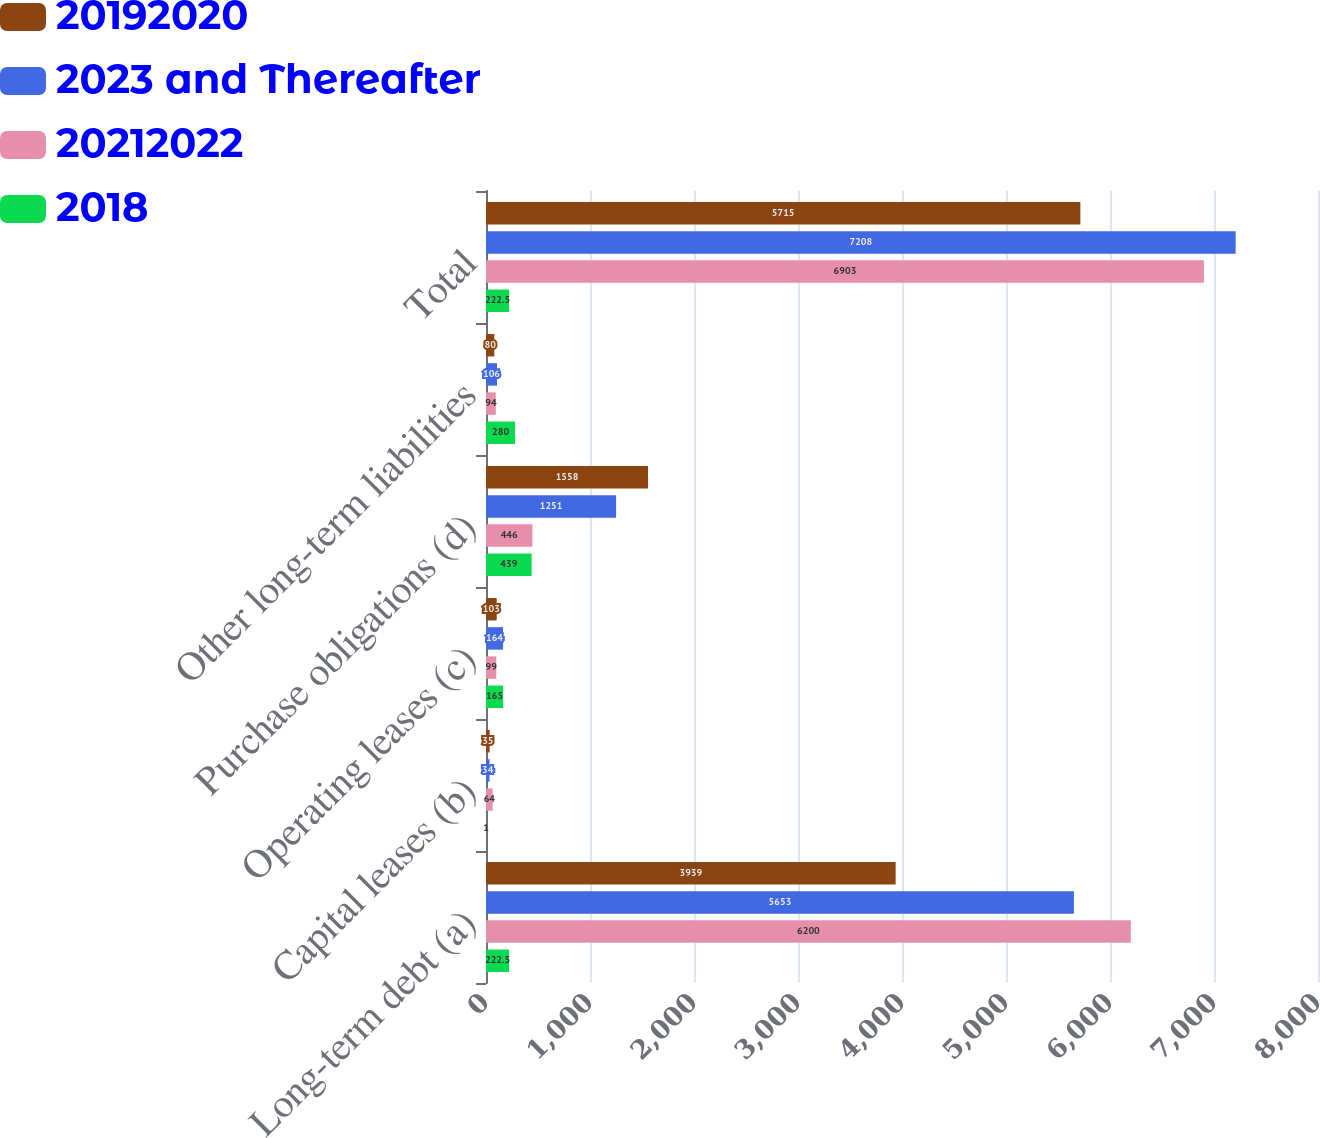Convert chart. <chart><loc_0><loc_0><loc_500><loc_500><stacked_bar_chart><ecel><fcel>Long-term debt (a)<fcel>Capital leases (b)<fcel>Operating leases (c)<fcel>Purchase obligations (d)<fcel>Other long-term liabilities<fcel>Total<nl><fcel>20192020<fcel>3939<fcel>35<fcel>103<fcel>1558<fcel>80<fcel>5715<nl><fcel>2023 and Thereafter<fcel>5653<fcel>34<fcel>164<fcel>1251<fcel>106<fcel>7208<nl><fcel>20212022<fcel>6200<fcel>64<fcel>99<fcel>446<fcel>94<fcel>6903<nl><fcel>2018<fcel>222.5<fcel>1<fcel>165<fcel>439<fcel>280<fcel>222.5<nl></chart> 